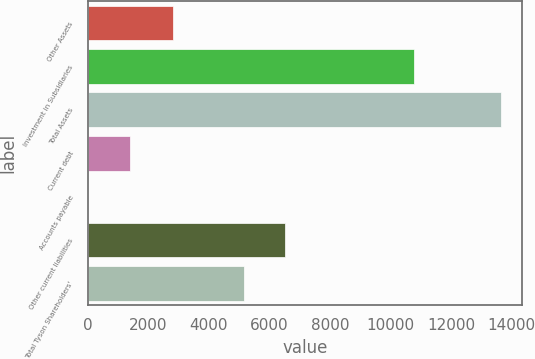<chart> <loc_0><loc_0><loc_500><loc_500><bar_chart><fcel>Other Assets<fcel>Investment in Subsidiaries<fcel>Total Assets<fcel>Current debt<fcel>Accounts payable<fcel>Other current liabilities<fcel>Total Tyson Shareholders'<nl><fcel>2804<fcel>10776<fcel>13664<fcel>1380.8<fcel>16<fcel>6530.8<fcel>5166<nl></chart> 